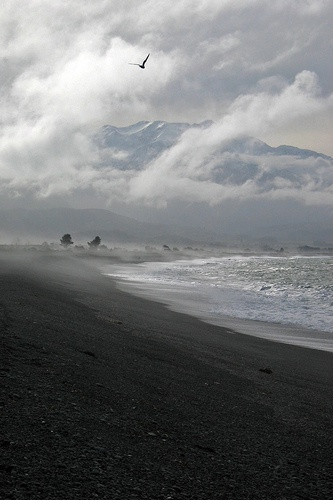Describe the objects in this image and their specific colors. I can see a bird in lightgray, black, darkgray, and gray tones in this image. 